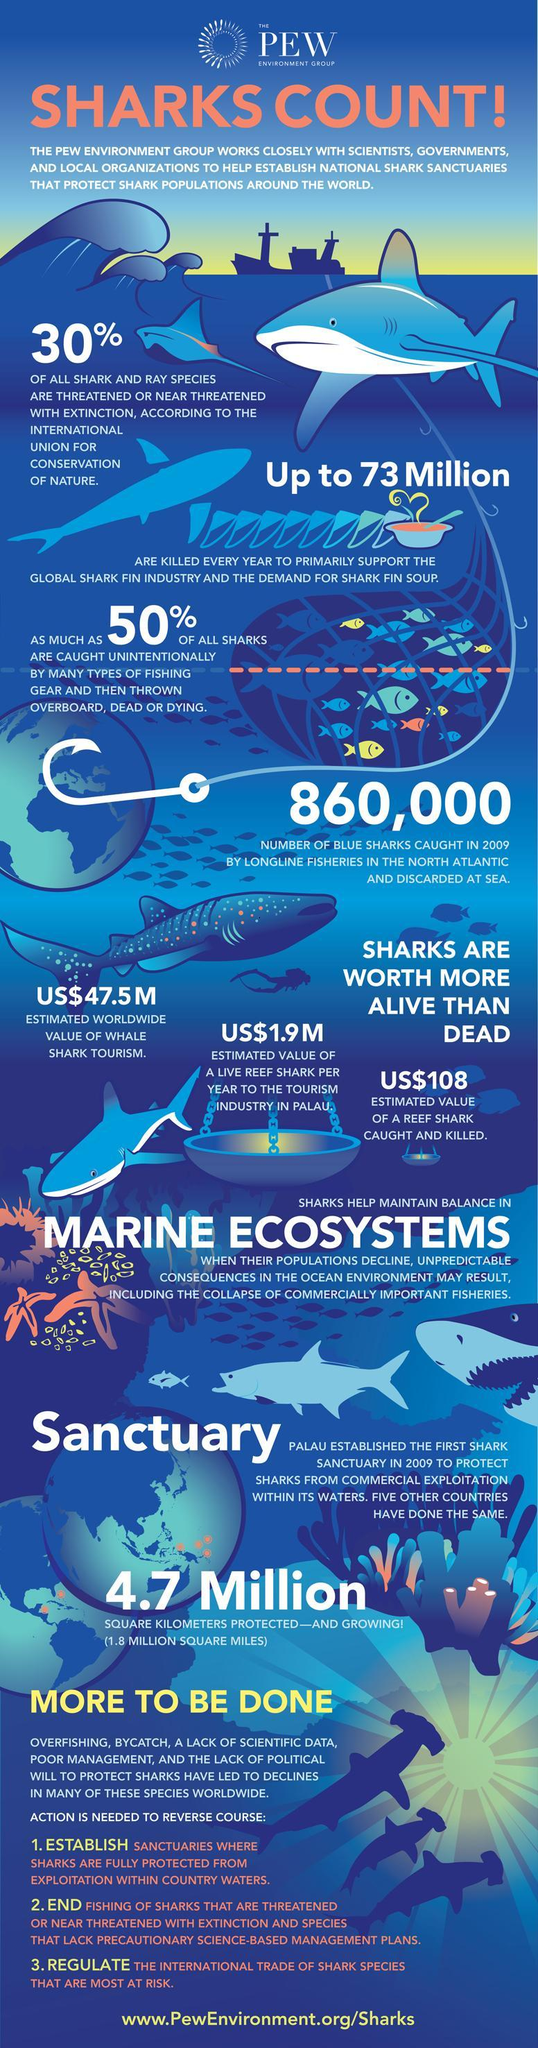What is the estimated value of a reef shark caught & killed?
Answer the question with a short phrase. US$108 